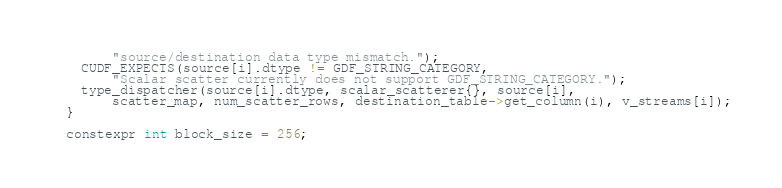Convert code to text. <code><loc_0><loc_0><loc_500><loc_500><_Cuda_>        "source/destination data type mismatch.");
    CUDF_EXPECTS(source[i].dtype != GDF_STRING_CATEGORY,
        "Scalar scatter currently does not support GDF_STRING_CATEGORY.");
    type_dispatcher(source[i].dtype, scalar_scatterer{}, source[i], 
        scatter_map, num_scatter_rows, destination_table->get_column(i), v_streams[i]);
  }

  constexpr int block_size = 256;  </code> 